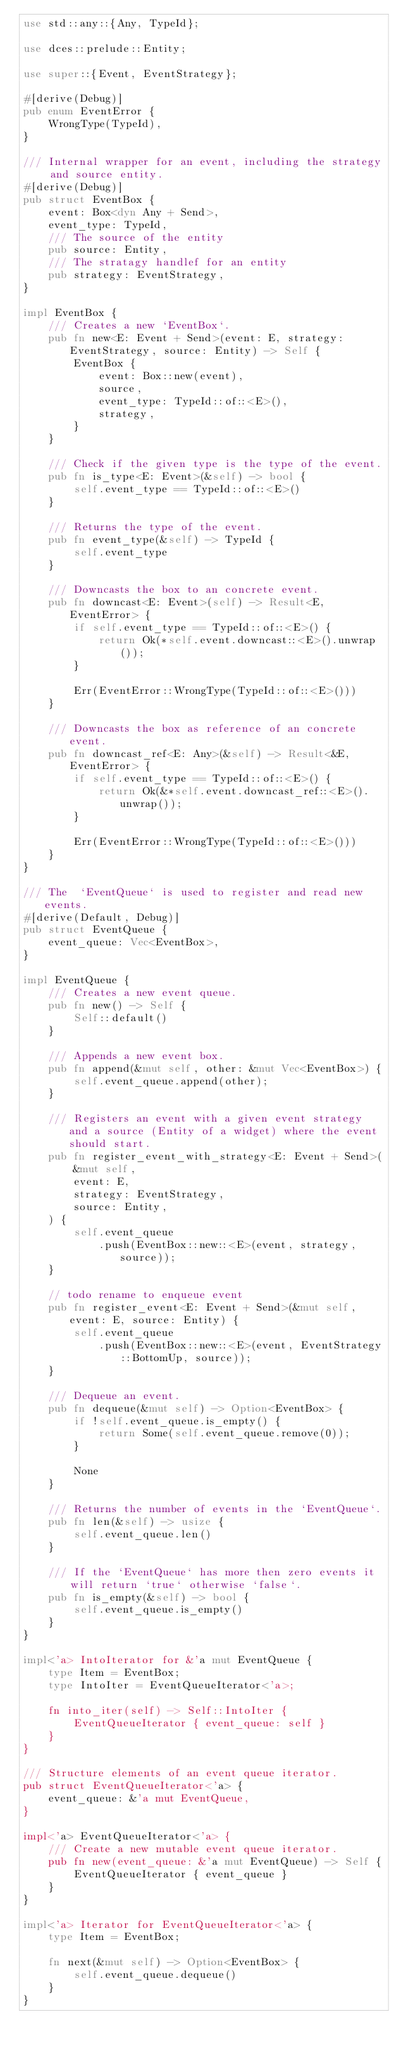Convert code to text. <code><loc_0><loc_0><loc_500><loc_500><_Rust_>use std::any::{Any, TypeId};

use dces::prelude::Entity;

use super::{Event, EventStrategy};

#[derive(Debug)]
pub enum EventError {
    WrongType(TypeId),
}

/// Internal wrapper for an event, including the strategy and source entity.
#[derive(Debug)]
pub struct EventBox {
    event: Box<dyn Any + Send>,
    event_type: TypeId,
    /// The source of the entity
    pub source: Entity,
    /// The stratagy handlef for an entity
    pub strategy: EventStrategy,
}

impl EventBox {
    /// Creates a new `EventBox`.
    pub fn new<E: Event + Send>(event: E, strategy: EventStrategy, source: Entity) -> Self {
        EventBox {
            event: Box::new(event),
            source,
            event_type: TypeId::of::<E>(),
            strategy,
        }
    }

    /// Check if the given type is the type of the event.
    pub fn is_type<E: Event>(&self) -> bool {
        self.event_type == TypeId::of::<E>()
    }

    /// Returns the type of the event.
    pub fn event_type(&self) -> TypeId {
        self.event_type
    }

    /// Downcasts the box to an concrete event.
    pub fn downcast<E: Event>(self) -> Result<E, EventError> {
        if self.event_type == TypeId::of::<E>() {
            return Ok(*self.event.downcast::<E>().unwrap());
        }

        Err(EventError::WrongType(TypeId::of::<E>()))
    }

    /// Downcasts the box as reference of an concrete event.
    pub fn downcast_ref<E: Any>(&self) -> Result<&E, EventError> {
        if self.event_type == TypeId::of::<E>() {
            return Ok(&*self.event.downcast_ref::<E>().unwrap());
        }

        Err(EventError::WrongType(TypeId::of::<E>()))
    }
}

/// The  `EventQueue` is used to register and read new events.
#[derive(Default, Debug)]
pub struct EventQueue {
    event_queue: Vec<EventBox>,
}

impl EventQueue {
    /// Creates a new event queue.
    pub fn new() -> Self {
        Self::default()
    }

    /// Appends a new event box.
    pub fn append(&mut self, other: &mut Vec<EventBox>) {
        self.event_queue.append(other);
    }

    /// Registers an event with a given event strategy and a source (Entity of a widget) where the event should start.
    pub fn register_event_with_strategy<E: Event + Send>(
        &mut self,
        event: E,
        strategy: EventStrategy,
        source: Entity,
    ) {
        self.event_queue
            .push(EventBox::new::<E>(event, strategy, source));
    }

    // todo rename to enqueue event
    pub fn register_event<E: Event + Send>(&mut self, event: E, source: Entity) {
        self.event_queue
            .push(EventBox::new::<E>(event, EventStrategy::BottomUp, source));
    }

    /// Dequeue an event.
    pub fn dequeue(&mut self) -> Option<EventBox> {
        if !self.event_queue.is_empty() {
            return Some(self.event_queue.remove(0));
        }

        None
    }

    /// Returns the number of events in the `EventQueue`.
    pub fn len(&self) -> usize {
        self.event_queue.len()
    }

    /// If the `EventQueue` has more then zero events it will return `true` otherwise `false`.
    pub fn is_empty(&self) -> bool {
        self.event_queue.is_empty()
    }
}

impl<'a> IntoIterator for &'a mut EventQueue {
    type Item = EventBox;
    type IntoIter = EventQueueIterator<'a>;

    fn into_iter(self) -> Self::IntoIter {
        EventQueueIterator { event_queue: self }
    }
}

/// Structure elements of an event queue iterator.
pub struct EventQueueIterator<'a> {
    event_queue: &'a mut EventQueue,
}

impl<'a> EventQueueIterator<'a> {
    /// Create a new mutable event queue iterator.
    pub fn new(event_queue: &'a mut EventQueue) -> Self {
        EventQueueIterator { event_queue }
    }
}

impl<'a> Iterator for EventQueueIterator<'a> {
    type Item = EventBox;

    fn next(&mut self) -> Option<EventBox> {
        self.event_queue.dequeue()
    }
}
</code> 